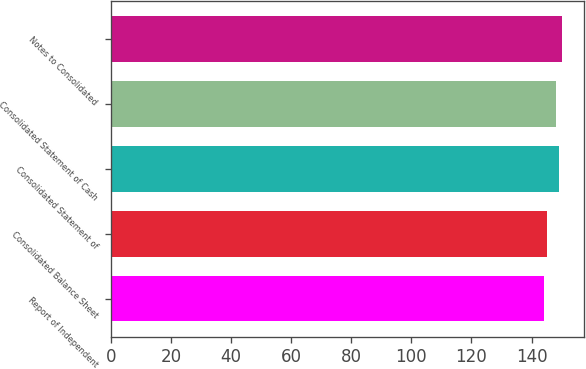<chart> <loc_0><loc_0><loc_500><loc_500><bar_chart><fcel>Report of Independent<fcel>Consolidated Balance Sheet<fcel>Consolidated Statement of<fcel>Consolidated Statement of Cash<fcel>Notes to Consolidated<nl><fcel>144<fcel>145<fcel>149<fcel>148<fcel>150<nl></chart> 